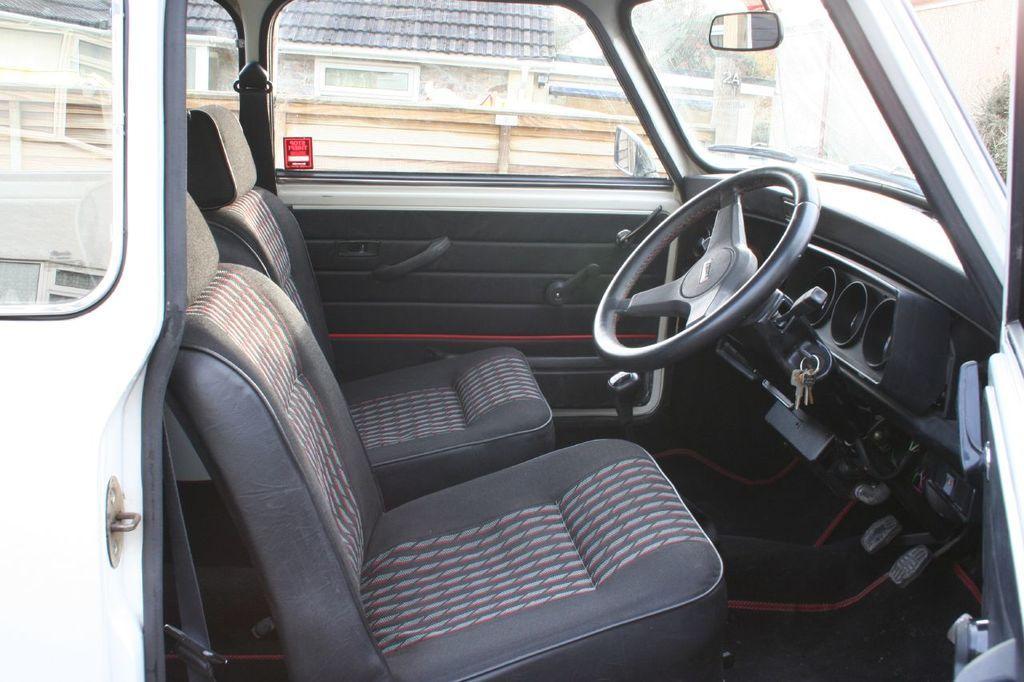Could you give a brief overview of what you see in this image? In this image we can see a vehicle and the door of the vehicle is opened. Through the glass of the vehicle, we can see a house and a wall. 